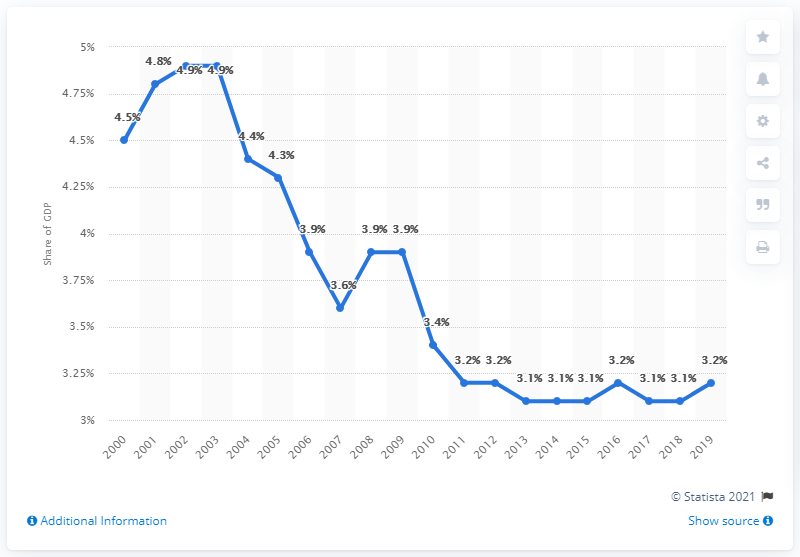Mention a couple of crucial points in this snapshot. According to data, approximately 3.2% of Singapore's gross domestic product is dedicated to military expenditure. 